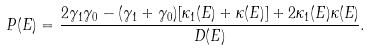Convert formula to latex. <formula><loc_0><loc_0><loc_500><loc_500>P ( E ) = \frac { 2 \gamma _ { 1 } \gamma _ { 0 } - ( \gamma _ { 1 } + \gamma _ { 0 } ) [ \kappa _ { 1 } ( E ) + \kappa ( E ) ] + 2 \kappa _ { 1 } ( E ) \kappa ( E ) } { D ( E ) } .</formula> 